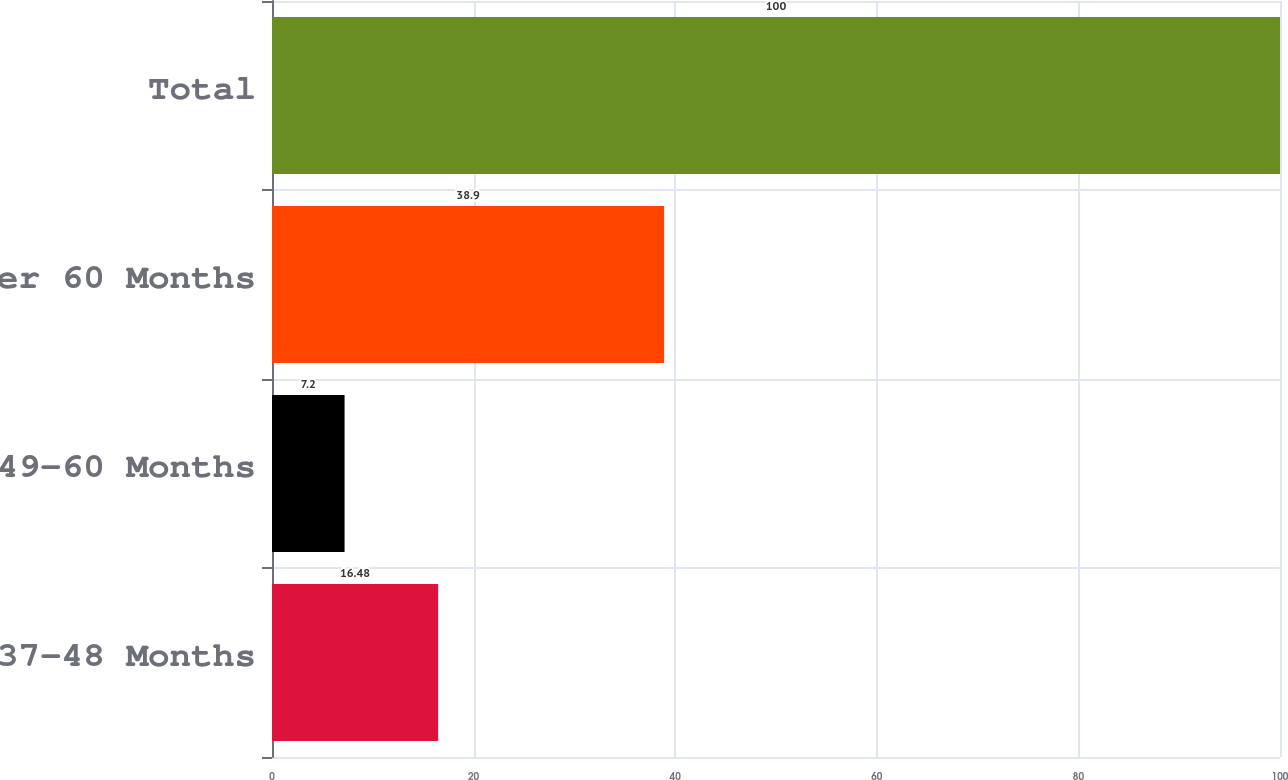<chart> <loc_0><loc_0><loc_500><loc_500><bar_chart><fcel>37-48 Months<fcel>49-60 Months<fcel>Over 60 Months<fcel>Total<nl><fcel>16.48<fcel>7.2<fcel>38.9<fcel>100<nl></chart> 